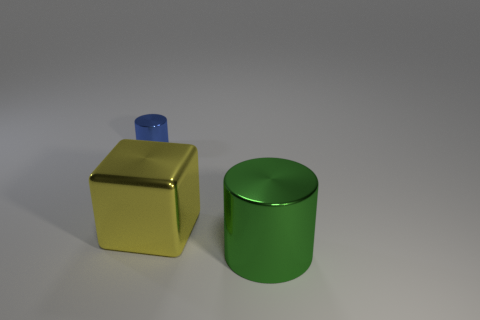Add 2 red metal objects. How many objects exist? 5 Subtract all blue cylinders. How many cylinders are left? 1 Subtract 1 cylinders. How many cylinders are left? 1 Subtract all blocks. How many objects are left? 2 Add 1 small blue objects. How many small blue objects are left? 2 Add 1 big cyan metallic cubes. How many big cyan metallic cubes exist? 1 Subtract 0 brown spheres. How many objects are left? 3 Subtract all blue cubes. Subtract all brown cylinders. How many cubes are left? 1 Subtract all big green spheres. Subtract all large shiny things. How many objects are left? 1 